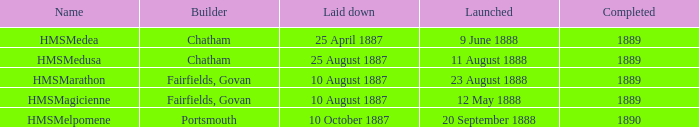What is the name of the boat that was built by Chatham and Laid down of 25 april 1887? HMSMedea. 